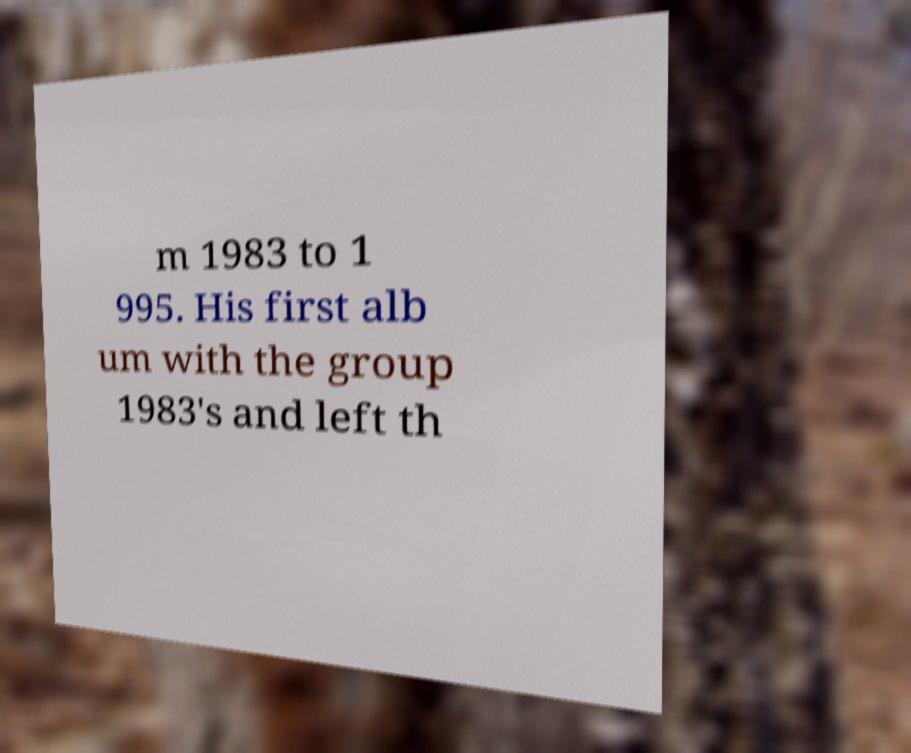Please identify and transcribe the text found in this image. m 1983 to 1 995. His first alb um with the group 1983's and left th 